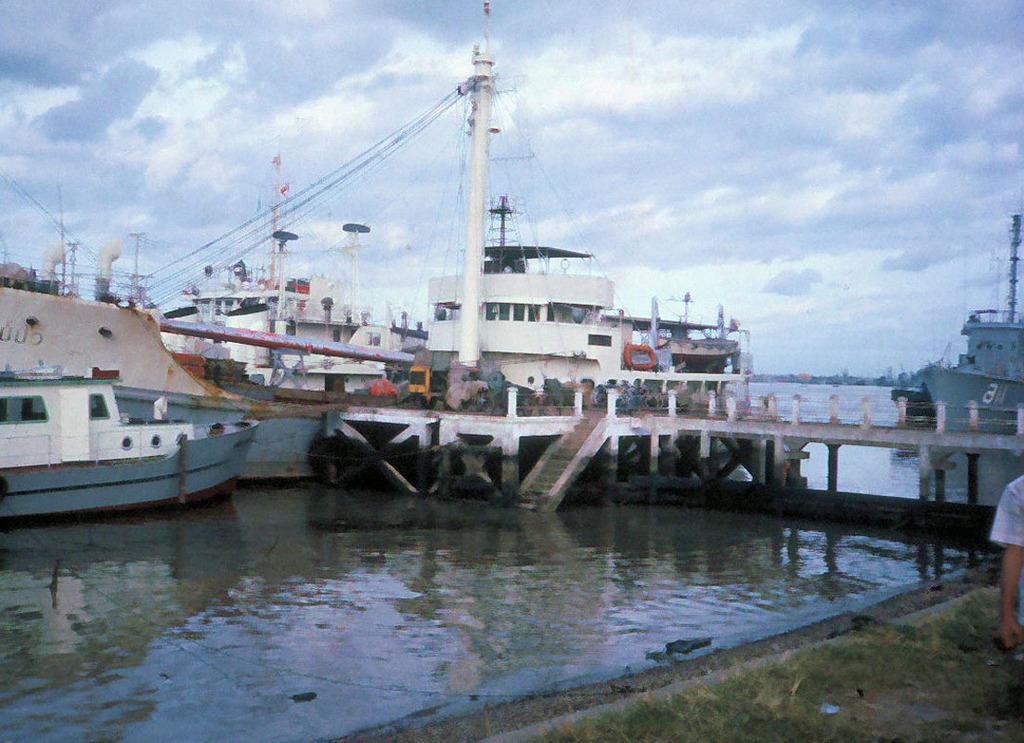How would you summarize this image in a sentence or two? In the picture we can see water and around it we can see a path and some part of a bridge with railing and on it we can see a pole with wires to it and behind it, we can see some boats and ships which are white in color and behind it we can see a sky with clouds. 